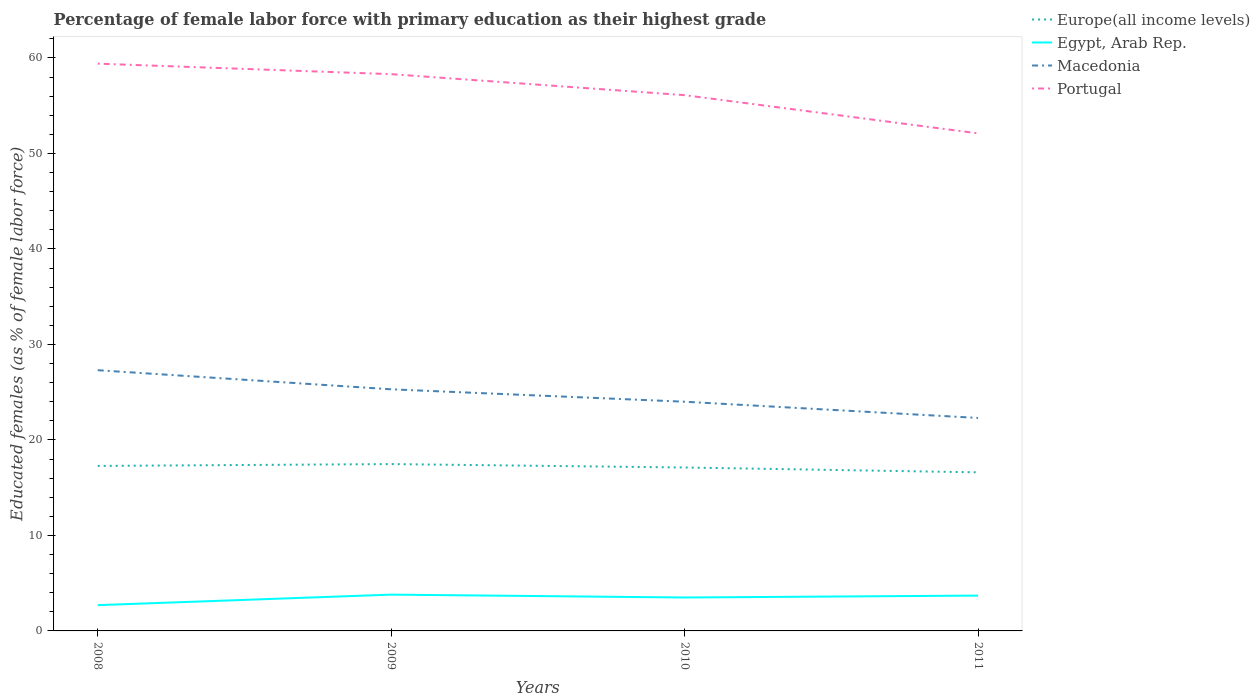Does the line corresponding to Macedonia intersect with the line corresponding to Europe(all income levels)?
Make the answer very short. No. Across all years, what is the maximum percentage of female labor force with primary education in Europe(all income levels)?
Offer a terse response. 16.61. In which year was the percentage of female labor force with primary education in Europe(all income levels) maximum?
Keep it short and to the point. 2011. What is the total percentage of female labor force with primary education in Europe(all income levels) in the graph?
Provide a short and direct response. 0.86. What is the difference between the highest and the second highest percentage of female labor force with primary education in Egypt, Arab Rep.?
Your answer should be compact. 1.1. What is the difference between the highest and the lowest percentage of female labor force with primary education in Europe(all income levels)?
Your answer should be compact. 2. How many years are there in the graph?
Ensure brevity in your answer.  4. What is the difference between two consecutive major ticks on the Y-axis?
Offer a very short reply. 10. Are the values on the major ticks of Y-axis written in scientific E-notation?
Keep it short and to the point. No. Does the graph contain any zero values?
Give a very brief answer. No. Does the graph contain grids?
Ensure brevity in your answer.  No. Where does the legend appear in the graph?
Keep it short and to the point. Top right. How many legend labels are there?
Ensure brevity in your answer.  4. What is the title of the graph?
Provide a short and direct response. Percentage of female labor force with primary education as their highest grade. Does "South Asia" appear as one of the legend labels in the graph?
Offer a terse response. No. What is the label or title of the Y-axis?
Offer a very short reply. Educated females (as % of female labor force). What is the Educated females (as % of female labor force) in Europe(all income levels) in 2008?
Provide a succinct answer. 17.28. What is the Educated females (as % of female labor force) in Egypt, Arab Rep. in 2008?
Your answer should be very brief. 2.7. What is the Educated females (as % of female labor force) in Macedonia in 2008?
Give a very brief answer. 27.3. What is the Educated females (as % of female labor force) in Portugal in 2008?
Give a very brief answer. 59.4. What is the Educated females (as % of female labor force) of Europe(all income levels) in 2009?
Offer a very short reply. 17.47. What is the Educated females (as % of female labor force) of Egypt, Arab Rep. in 2009?
Ensure brevity in your answer.  3.8. What is the Educated females (as % of female labor force) of Macedonia in 2009?
Provide a succinct answer. 25.3. What is the Educated females (as % of female labor force) in Portugal in 2009?
Provide a short and direct response. 58.3. What is the Educated females (as % of female labor force) in Europe(all income levels) in 2010?
Keep it short and to the point. 17.11. What is the Educated females (as % of female labor force) of Egypt, Arab Rep. in 2010?
Your answer should be very brief. 3.5. What is the Educated females (as % of female labor force) in Portugal in 2010?
Your answer should be compact. 56.1. What is the Educated females (as % of female labor force) of Europe(all income levels) in 2011?
Make the answer very short. 16.61. What is the Educated females (as % of female labor force) of Egypt, Arab Rep. in 2011?
Ensure brevity in your answer.  3.7. What is the Educated females (as % of female labor force) in Macedonia in 2011?
Your answer should be very brief. 22.3. What is the Educated females (as % of female labor force) in Portugal in 2011?
Make the answer very short. 52.1. Across all years, what is the maximum Educated females (as % of female labor force) of Europe(all income levels)?
Offer a very short reply. 17.47. Across all years, what is the maximum Educated females (as % of female labor force) of Egypt, Arab Rep.?
Your answer should be very brief. 3.8. Across all years, what is the maximum Educated females (as % of female labor force) of Macedonia?
Keep it short and to the point. 27.3. Across all years, what is the maximum Educated females (as % of female labor force) of Portugal?
Offer a terse response. 59.4. Across all years, what is the minimum Educated females (as % of female labor force) in Europe(all income levels)?
Your answer should be compact. 16.61. Across all years, what is the minimum Educated females (as % of female labor force) of Egypt, Arab Rep.?
Provide a succinct answer. 2.7. Across all years, what is the minimum Educated females (as % of female labor force) of Macedonia?
Make the answer very short. 22.3. Across all years, what is the minimum Educated females (as % of female labor force) in Portugal?
Offer a terse response. 52.1. What is the total Educated females (as % of female labor force) of Europe(all income levels) in the graph?
Provide a short and direct response. 68.47. What is the total Educated females (as % of female labor force) of Macedonia in the graph?
Your answer should be very brief. 98.9. What is the total Educated females (as % of female labor force) in Portugal in the graph?
Your answer should be very brief. 225.9. What is the difference between the Educated females (as % of female labor force) of Europe(all income levels) in 2008 and that in 2009?
Provide a short and direct response. -0.19. What is the difference between the Educated females (as % of female labor force) of Portugal in 2008 and that in 2009?
Keep it short and to the point. 1.1. What is the difference between the Educated females (as % of female labor force) of Europe(all income levels) in 2008 and that in 2010?
Provide a short and direct response. 0.17. What is the difference between the Educated females (as % of female labor force) of Egypt, Arab Rep. in 2008 and that in 2010?
Provide a succinct answer. -0.8. What is the difference between the Educated females (as % of female labor force) in Portugal in 2008 and that in 2010?
Offer a very short reply. 3.3. What is the difference between the Educated females (as % of female labor force) in Europe(all income levels) in 2008 and that in 2011?
Ensure brevity in your answer.  0.67. What is the difference between the Educated females (as % of female labor force) of Egypt, Arab Rep. in 2008 and that in 2011?
Your answer should be compact. -1. What is the difference between the Educated females (as % of female labor force) in Macedonia in 2008 and that in 2011?
Your answer should be compact. 5. What is the difference between the Educated females (as % of female labor force) in Portugal in 2008 and that in 2011?
Make the answer very short. 7.3. What is the difference between the Educated females (as % of female labor force) in Europe(all income levels) in 2009 and that in 2010?
Give a very brief answer. 0.36. What is the difference between the Educated females (as % of female labor force) of Egypt, Arab Rep. in 2009 and that in 2010?
Offer a very short reply. 0.3. What is the difference between the Educated females (as % of female labor force) in Portugal in 2009 and that in 2010?
Keep it short and to the point. 2.2. What is the difference between the Educated females (as % of female labor force) of Europe(all income levels) in 2009 and that in 2011?
Provide a succinct answer. 0.86. What is the difference between the Educated females (as % of female labor force) of Egypt, Arab Rep. in 2009 and that in 2011?
Keep it short and to the point. 0.1. What is the difference between the Educated females (as % of female labor force) of Macedonia in 2009 and that in 2011?
Keep it short and to the point. 3. What is the difference between the Educated females (as % of female labor force) in Portugal in 2009 and that in 2011?
Provide a succinct answer. 6.2. What is the difference between the Educated females (as % of female labor force) in Europe(all income levels) in 2010 and that in 2011?
Ensure brevity in your answer.  0.51. What is the difference between the Educated females (as % of female labor force) of Portugal in 2010 and that in 2011?
Make the answer very short. 4. What is the difference between the Educated females (as % of female labor force) of Europe(all income levels) in 2008 and the Educated females (as % of female labor force) of Egypt, Arab Rep. in 2009?
Give a very brief answer. 13.48. What is the difference between the Educated females (as % of female labor force) of Europe(all income levels) in 2008 and the Educated females (as % of female labor force) of Macedonia in 2009?
Provide a succinct answer. -8.02. What is the difference between the Educated females (as % of female labor force) in Europe(all income levels) in 2008 and the Educated females (as % of female labor force) in Portugal in 2009?
Provide a short and direct response. -41.02. What is the difference between the Educated females (as % of female labor force) in Egypt, Arab Rep. in 2008 and the Educated females (as % of female labor force) in Macedonia in 2009?
Keep it short and to the point. -22.6. What is the difference between the Educated females (as % of female labor force) in Egypt, Arab Rep. in 2008 and the Educated females (as % of female labor force) in Portugal in 2009?
Your answer should be very brief. -55.6. What is the difference between the Educated females (as % of female labor force) in Macedonia in 2008 and the Educated females (as % of female labor force) in Portugal in 2009?
Ensure brevity in your answer.  -31. What is the difference between the Educated females (as % of female labor force) of Europe(all income levels) in 2008 and the Educated females (as % of female labor force) of Egypt, Arab Rep. in 2010?
Offer a terse response. 13.78. What is the difference between the Educated females (as % of female labor force) in Europe(all income levels) in 2008 and the Educated females (as % of female labor force) in Macedonia in 2010?
Your response must be concise. -6.72. What is the difference between the Educated females (as % of female labor force) in Europe(all income levels) in 2008 and the Educated females (as % of female labor force) in Portugal in 2010?
Provide a short and direct response. -38.82. What is the difference between the Educated females (as % of female labor force) in Egypt, Arab Rep. in 2008 and the Educated females (as % of female labor force) in Macedonia in 2010?
Your answer should be very brief. -21.3. What is the difference between the Educated females (as % of female labor force) in Egypt, Arab Rep. in 2008 and the Educated females (as % of female labor force) in Portugal in 2010?
Ensure brevity in your answer.  -53.4. What is the difference between the Educated females (as % of female labor force) of Macedonia in 2008 and the Educated females (as % of female labor force) of Portugal in 2010?
Ensure brevity in your answer.  -28.8. What is the difference between the Educated females (as % of female labor force) in Europe(all income levels) in 2008 and the Educated females (as % of female labor force) in Egypt, Arab Rep. in 2011?
Provide a succinct answer. 13.58. What is the difference between the Educated females (as % of female labor force) in Europe(all income levels) in 2008 and the Educated females (as % of female labor force) in Macedonia in 2011?
Give a very brief answer. -5.02. What is the difference between the Educated females (as % of female labor force) in Europe(all income levels) in 2008 and the Educated females (as % of female labor force) in Portugal in 2011?
Your response must be concise. -34.82. What is the difference between the Educated females (as % of female labor force) of Egypt, Arab Rep. in 2008 and the Educated females (as % of female labor force) of Macedonia in 2011?
Keep it short and to the point. -19.6. What is the difference between the Educated females (as % of female labor force) in Egypt, Arab Rep. in 2008 and the Educated females (as % of female labor force) in Portugal in 2011?
Your response must be concise. -49.4. What is the difference between the Educated females (as % of female labor force) of Macedonia in 2008 and the Educated females (as % of female labor force) of Portugal in 2011?
Your answer should be very brief. -24.8. What is the difference between the Educated females (as % of female labor force) of Europe(all income levels) in 2009 and the Educated females (as % of female labor force) of Egypt, Arab Rep. in 2010?
Your answer should be very brief. 13.97. What is the difference between the Educated females (as % of female labor force) in Europe(all income levels) in 2009 and the Educated females (as % of female labor force) in Macedonia in 2010?
Provide a short and direct response. -6.53. What is the difference between the Educated females (as % of female labor force) in Europe(all income levels) in 2009 and the Educated females (as % of female labor force) in Portugal in 2010?
Your response must be concise. -38.63. What is the difference between the Educated females (as % of female labor force) in Egypt, Arab Rep. in 2009 and the Educated females (as % of female labor force) in Macedonia in 2010?
Provide a short and direct response. -20.2. What is the difference between the Educated females (as % of female labor force) in Egypt, Arab Rep. in 2009 and the Educated females (as % of female labor force) in Portugal in 2010?
Offer a terse response. -52.3. What is the difference between the Educated females (as % of female labor force) of Macedonia in 2009 and the Educated females (as % of female labor force) of Portugal in 2010?
Your answer should be very brief. -30.8. What is the difference between the Educated females (as % of female labor force) in Europe(all income levels) in 2009 and the Educated females (as % of female labor force) in Egypt, Arab Rep. in 2011?
Make the answer very short. 13.77. What is the difference between the Educated females (as % of female labor force) in Europe(all income levels) in 2009 and the Educated females (as % of female labor force) in Macedonia in 2011?
Your answer should be compact. -4.83. What is the difference between the Educated females (as % of female labor force) of Europe(all income levels) in 2009 and the Educated females (as % of female labor force) of Portugal in 2011?
Ensure brevity in your answer.  -34.63. What is the difference between the Educated females (as % of female labor force) in Egypt, Arab Rep. in 2009 and the Educated females (as % of female labor force) in Macedonia in 2011?
Provide a succinct answer. -18.5. What is the difference between the Educated females (as % of female labor force) in Egypt, Arab Rep. in 2009 and the Educated females (as % of female labor force) in Portugal in 2011?
Make the answer very short. -48.3. What is the difference between the Educated females (as % of female labor force) in Macedonia in 2009 and the Educated females (as % of female labor force) in Portugal in 2011?
Provide a short and direct response. -26.8. What is the difference between the Educated females (as % of female labor force) in Europe(all income levels) in 2010 and the Educated females (as % of female labor force) in Egypt, Arab Rep. in 2011?
Your response must be concise. 13.41. What is the difference between the Educated females (as % of female labor force) in Europe(all income levels) in 2010 and the Educated females (as % of female labor force) in Macedonia in 2011?
Your answer should be very brief. -5.19. What is the difference between the Educated females (as % of female labor force) in Europe(all income levels) in 2010 and the Educated females (as % of female labor force) in Portugal in 2011?
Keep it short and to the point. -34.99. What is the difference between the Educated females (as % of female labor force) of Egypt, Arab Rep. in 2010 and the Educated females (as % of female labor force) of Macedonia in 2011?
Give a very brief answer. -18.8. What is the difference between the Educated females (as % of female labor force) of Egypt, Arab Rep. in 2010 and the Educated females (as % of female labor force) of Portugal in 2011?
Provide a short and direct response. -48.6. What is the difference between the Educated females (as % of female labor force) in Macedonia in 2010 and the Educated females (as % of female labor force) in Portugal in 2011?
Make the answer very short. -28.1. What is the average Educated females (as % of female labor force) of Europe(all income levels) per year?
Provide a short and direct response. 17.12. What is the average Educated females (as % of female labor force) in Egypt, Arab Rep. per year?
Your answer should be very brief. 3.42. What is the average Educated females (as % of female labor force) of Macedonia per year?
Give a very brief answer. 24.73. What is the average Educated females (as % of female labor force) in Portugal per year?
Ensure brevity in your answer.  56.48. In the year 2008, what is the difference between the Educated females (as % of female labor force) of Europe(all income levels) and Educated females (as % of female labor force) of Egypt, Arab Rep.?
Provide a succinct answer. 14.58. In the year 2008, what is the difference between the Educated females (as % of female labor force) of Europe(all income levels) and Educated females (as % of female labor force) of Macedonia?
Offer a very short reply. -10.02. In the year 2008, what is the difference between the Educated females (as % of female labor force) in Europe(all income levels) and Educated females (as % of female labor force) in Portugal?
Your response must be concise. -42.12. In the year 2008, what is the difference between the Educated females (as % of female labor force) in Egypt, Arab Rep. and Educated females (as % of female labor force) in Macedonia?
Provide a succinct answer. -24.6. In the year 2008, what is the difference between the Educated females (as % of female labor force) of Egypt, Arab Rep. and Educated females (as % of female labor force) of Portugal?
Give a very brief answer. -56.7. In the year 2008, what is the difference between the Educated females (as % of female labor force) in Macedonia and Educated females (as % of female labor force) in Portugal?
Give a very brief answer. -32.1. In the year 2009, what is the difference between the Educated females (as % of female labor force) in Europe(all income levels) and Educated females (as % of female labor force) in Egypt, Arab Rep.?
Your response must be concise. 13.67. In the year 2009, what is the difference between the Educated females (as % of female labor force) in Europe(all income levels) and Educated females (as % of female labor force) in Macedonia?
Make the answer very short. -7.83. In the year 2009, what is the difference between the Educated females (as % of female labor force) of Europe(all income levels) and Educated females (as % of female labor force) of Portugal?
Ensure brevity in your answer.  -40.83. In the year 2009, what is the difference between the Educated females (as % of female labor force) in Egypt, Arab Rep. and Educated females (as % of female labor force) in Macedonia?
Give a very brief answer. -21.5. In the year 2009, what is the difference between the Educated females (as % of female labor force) in Egypt, Arab Rep. and Educated females (as % of female labor force) in Portugal?
Offer a terse response. -54.5. In the year 2009, what is the difference between the Educated females (as % of female labor force) in Macedonia and Educated females (as % of female labor force) in Portugal?
Your answer should be compact. -33. In the year 2010, what is the difference between the Educated females (as % of female labor force) of Europe(all income levels) and Educated females (as % of female labor force) of Egypt, Arab Rep.?
Your response must be concise. 13.61. In the year 2010, what is the difference between the Educated females (as % of female labor force) in Europe(all income levels) and Educated females (as % of female labor force) in Macedonia?
Make the answer very short. -6.89. In the year 2010, what is the difference between the Educated females (as % of female labor force) of Europe(all income levels) and Educated females (as % of female labor force) of Portugal?
Keep it short and to the point. -38.99. In the year 2010, what is the difference between the Educated females (as % of female labor force) of Egypt, Arab Rep. and Educated females (as % of female labor force) of Macedonia?
Your response must be concise. -20.5. In the year 2010, what is the difference between the Educated females (as % of female labor force) of Egypt, Arab Rep. and Educated females (as % of female labor force) of Portugal?
Give a very brief answer. -52.6. In the year 2010, what is the difference between the Educated females (as % of female labor force) in Macedonia and Educated females (as % of female labor force) in Portugal?
Ensure brevity in your answer.  -32.1. In the year 2011, what is the difference between the Educated females (as % of female labor force) of Europe(all income levels) and Educated females (as % of female labor force) of Egypt, Arab Rep.?
Offer a very short reply. 12.91. In the year 2011, what is the difference between the Educated females (as % of female labor force) in Europe(all income levels) and Educated females (as % of female labor force) in Macedonia?
Keep it short and to the point. -5.69. In the year 2011, what is the difference between the Educated females (as % of female labor force) in Europe(all income levels) and Educated females (as % of female labor force) in Portugal?
Keep it short and to the point. -35.49. In the year 2011, what is the difference between the Educated females (as % of female labor force) of Egypt, Arab Rep. and Educated females (as % of female labor force) of Macedonia?
Offer a terse response. -18.6. In the year 2011, what is the difference between the Educated females (as % of female labor force) in Egypt, Arab Rep. and Educated females (as % of female labor force) in Portugal?
Your answer should be compact. -48.4. In the year 2011, what is the difference between the Educated females (as % of female labor force) of Macedonia and Educated females (as % of female labor force) of Portugal?
Make the answer very short. -29.8. What is the ratio of the Educated females (as % of female labor force) in Europe(all income levels) in 2008 to that in 2009?
Ensure brevity in your answer.  0.99. What is the ratio of the Educated females (as % of female labor force) in Egypt, Arab Rep. in 2008 to that in 2009?
Your answer should be very brief. 0.71. What is the ratio of the Educated females (as % of female labor force) of Macedonia in 2008 to that in 2009?
Your answer should be compact. 1.08. What is the ratio of the Educated females (as % of female labor force) of Portugal in 2008 to that in 2009?
Your answer should be compact. 1.02. What is the ratio of the Educated females (as % of female labor force) of Europe(all income levels) in 2008 to that in 2010?
Provide a short and direct response. 1.01. What is the ratio of the Educated females (as % of female labor force) of Egypt, Arab Rep. in 2008 to that in 2010?
Your answer should be compact. 0.77. What is the ratio of the Educated females (as % of female labor force) in Macedonia in 2008 to that in 2010?
Provide a short and direct response. 1.14. What is the ratio of the Educated females (as % of female labor force) in Portugal in 2008 to that in 2010?
Give a very brief answer. 1.06. What is the ratio of the Educated females (as % of female labor force) in Europe(all income levels) in 2008 to that in 2011?
Your response must be concise. 1.04. What is the ratio of the Educated females (as % of female labor force) of Egypt, Arab Rep. in 2008 to that in 2011?
Make the answer very short. 0.73. What is the ratio of the Educated females (as % of female labor force) of Macedonia in 2008 to that in 2011?
Your answer should be very brief. 1.22. What is the ratio of the Educated females (as % of female labor force) of Portugal in 2008 to that in 2011?
Your answer should be very brief. 1.14. What is the ratio of the Educated females (as % of female labor force) of Europe(all income levels) in 2009 to that in 2010?
Provide a succinct answer. 1.02. What is the ratio of the Educated females (as % of female labor force) in Egypt, Arab Rep. in 2009 to that in 2010?
Give a very brief answer. 1.09. What is the ratio of the Educated females (as % of female labor force) in Macedonia in 2009 to that in 2010?
Provide a succinct answer. 1.05. What is the ratio of the Educated females (as % of female labor force) in Portugal in 2009 to that in 2010?
Offer a very short reply. 1.04. What is the ratio of the Educated females (as % of female labor force) of Europe(all income levels) in 2009 to that in 2011?
Keep it short and to the point. 1.05. What is the ratio of the Educated females (as % of female labor force) in Egypt, Arab Rep. in 2009 to that in 2011?
Provide a short and direct response. 1.03. What is the ratio of the Educated females (as % of female labor force) in Macedonia in 2009 to that in 2011?
Provide a succinct answer. 1.13. What is the ratio of the Educated females (as % of female labor force) in Portugal in 2009 to that in 2011?
Your answer should be very brief. 1.12. What is the ratio of the Educated females (as % of female labor force) in Europe(all income levels) in 2010 to that in 2011?
Provide a succinct answer. 1.03. What is the ratio of the Educated females (as % of female labor force) in Egypt, Arab Rep. in 2010 to that in 2011?
Give a very brief answer. 0.95. What is the ratio of the Educated females (as % of female labor force) in Macedonia in 2010 to that in 2011?
Ensure brevity in your answer.  1.08. What is the ratio of the Educated females (as % of female labor force) in Portugal in 2010 to that in 2011?
Your response must be concise. 1.08. What is the difference between the highest and the second highest Educated females (as % of female labor force) of Europe(all income levels)?
Give a very brief answer. 0.19. What is the difference between the highest and the second highest Educated females (as % of female labor force) in Macedonia?
Make the answer very short. 2. What is the difference between the highest and the second highest Educated females (as % of female labor force) in Portugal?
Offer a terse response. 1.1. What is the difference between the highest and the lowest Educated females (as % of female labor force) of Europe(all income levels)?
Provide a succinct answer. 0.86. What is the difference between the highest and the lowest Educated females (as % of female labor force) of Macedonia?
Keep it short and to the point. 5. What is the difference between the highest and the lowest Educated females (as % of female labor force) in Portugal?
Give a very brief answer. 7.3. 